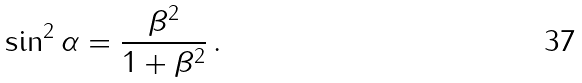Convert formula to latex. <formula><loc_0><loc_0><loc_500><loc_500>\sin ^ { 2 } \alpha = \frac { \beta ^ { 2 } } { 1 + \beta ^ { 2 } } \, .</formula> 